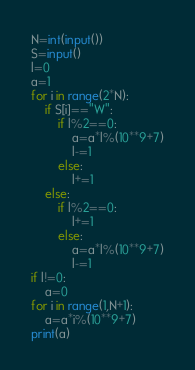<code> <loc_0><loc_0><loc_500><loc_500><_Python_>N=int(input())
S=input()
l=0
a=1
for i in range(2*N):
    if S[i]=="W":
        if l%2==0:
            a=a*l%(10**9+7)
            l-=1
        else:
            l+=1
    else:
        if l%2==0:
            l+=1
        else:
            a=a*l%(10**9+7)
            l-=1
if l!=0:
    a=0
for i in range(1,N+1):
    a=a*i%(10**9+7)
print(a)</code> 